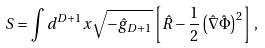<formula> <loc_0><loc_0><loc_500><loc_500>S = \int d ^ { D + 1 } x \sqrt { - \hat { g } _ { D + 1 } } \left [ \hat { R } - \frac { 1 } { 2 } \left ( \hat { \nabla } \hat { \Phi } \right ) ^ { 2 } \right ] \, ,</formula> 